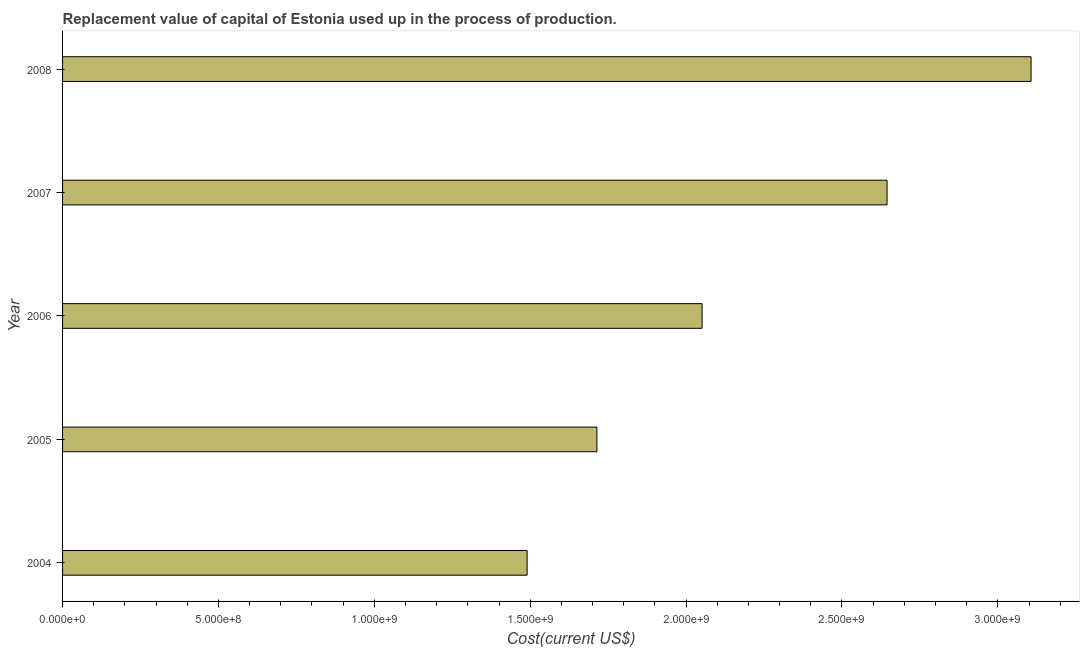Does the graph contain grids?
Your answer should be very brief. No. What is the title of the graph?
Provide a short and direct response. Replacement value of capital of Estonia used up in the process of production. What is the label or title of the X-axis?
Offer a terse response. Cost(current US$). What is the label or title of the Y-axis?
Ensure brevity in your answer.  Year. What is the consumption of fixed capital in 2006?
Keep it short and to the point. 2.05e+09. Across all years, what is the maximum consumption of fixed capital?
Offer a terse response. 3.11e+09. Across all years, what is the minimum consumption of fixed capital?
Offer a very short reply. 1.49e+09. In which year was the consumption of fixed capital maximum?
Offer a terse response. 2008. In which year was the consumption of fixed capital minimum?
Keep it short and to the point. 2004. What is the sum of the consumption of fixed capital?
Provide a short and direct response. 1.10e+1. What is the difference between the consumption of fixed capital in 2004 and 2005?
Provide a succinct answer. -2.24e+08. What is the average consumption of fixed capital per year?
Make the answer very short. 2.20e+09. What is the median consumption of fixed capital?
Offer a very short reply. 2.05e+09. What is the ratio of the consumption of fixed capital in 2005 to that in 2007?
Provide a succinct answer. 0.65. Is the consumption of fixed capital in 2007 less than that in 2008?
Ensure brevity in your answer.  Yes. Is the difference between the consumption of fixed capital in 2004 and 2008 greater than the difference between any two years?
Provide a succinct answer. Yes. What is the difference between the highest and the second highest consumption of fixed capital?
Your response must be concise. 4.62e+08. What is the difference between the highest and the lowest consumption of fixed capital?
Keep it short and to the point. 1.62e+09. What is the difference between two consecutive major ticks on the X-axis?
Make the answer very short. 5.00e+08. Are the values on the major ticks of X-axis written in scientific E-notation?
Keep it short and to the point. Yes. What is the Cost(current US$) of 2004?
Your response must be concise. 1.49e+09. What is the Cost(current US$) of 2005?
Give a very brief answer. 1.71e+09. What is the Cost(current US$) of 2006?
Make the answer very short. 2.05e+09. What is the Cost(current US$) of 2007?
Your answer should be very brief. 2.64e+09. What is the Cost(current US$) of 2008?
Offer a very short reply. 3.11e+09. What is the difference between the Cost(current US$) in 2004 and 2005?
Offer a very short reply. -2.24e+08. What is the difference between the Cost(current US$) in 2004 and 2006?
Keep it short and to the point. -5.61e+08. What is the difference between the Cost(current US$) in 2004 and 2007?
Your answer should be compact. -1.15e+09. What is the difference between the Cost(current US$) in 2004 and 2008?
Your response must be concise. -1.62e+09. What is the difference between the Cost(current US$) in 2005 and 2006?
Your response must be concise. -3.37e+08. What is the difference between the Cost(current US$) in 2005 and 2007?
Your response must be concise. -9.31e+08. What is the difference between the Cost(current US$) in 2005 and 2008?
Provide a succinct answer. -1.39e+09. What is the difference between the Cost(current US$) in 2006 and 2007?
Your response must be concise. -5.93e+08. What is the difference between the Cost(current US$) in 2006 and 2008?
Make the answer very short. -1.06e+09. What is the difference between the Cost(current US$) in 2007 and 2008?
Ensure brevity in your answer.  -4.62e+08. What is the ratio of the Cost(current US$) in 2004 to that in 2005?
Give a very brief answer. 0.87. What is the ratio of the Cost(current US$) in 2004 to that in 2006?
Offer a terse response. 0.73. What is the ratio of the Cost(current US$) in 2004 to that in 2007?
Ensure brevity in your answer.  0.56. What is the ratio of the Cost(current US$) in 2004 to that in 2008?
Your answer should be compact. 0.48. What is the ratio of the Cost(current US$) in 2005 to that in 2006?
Provide a succinct answer. 0.84. What is the ratio of the Cost(current US$) in 2005 to that in 2007?
Your answer should be very brief. 0.65. What is the ratio of the Cost(current US$) in 2005 to that in 2008?
Offer a terse response. 0.55. What is the ratio of the Cost(current US$) in 2006 to that in 2007?
Give a very brief answer. 0.78. What is the ratio of the Cost(current US$) in 2006 to that in 2008?
Give a very brief answer. 0.66. What is the ratio of the Cost(current US$) in 2007 to that in 2008?
Your answer should be very brief. 0.85. 